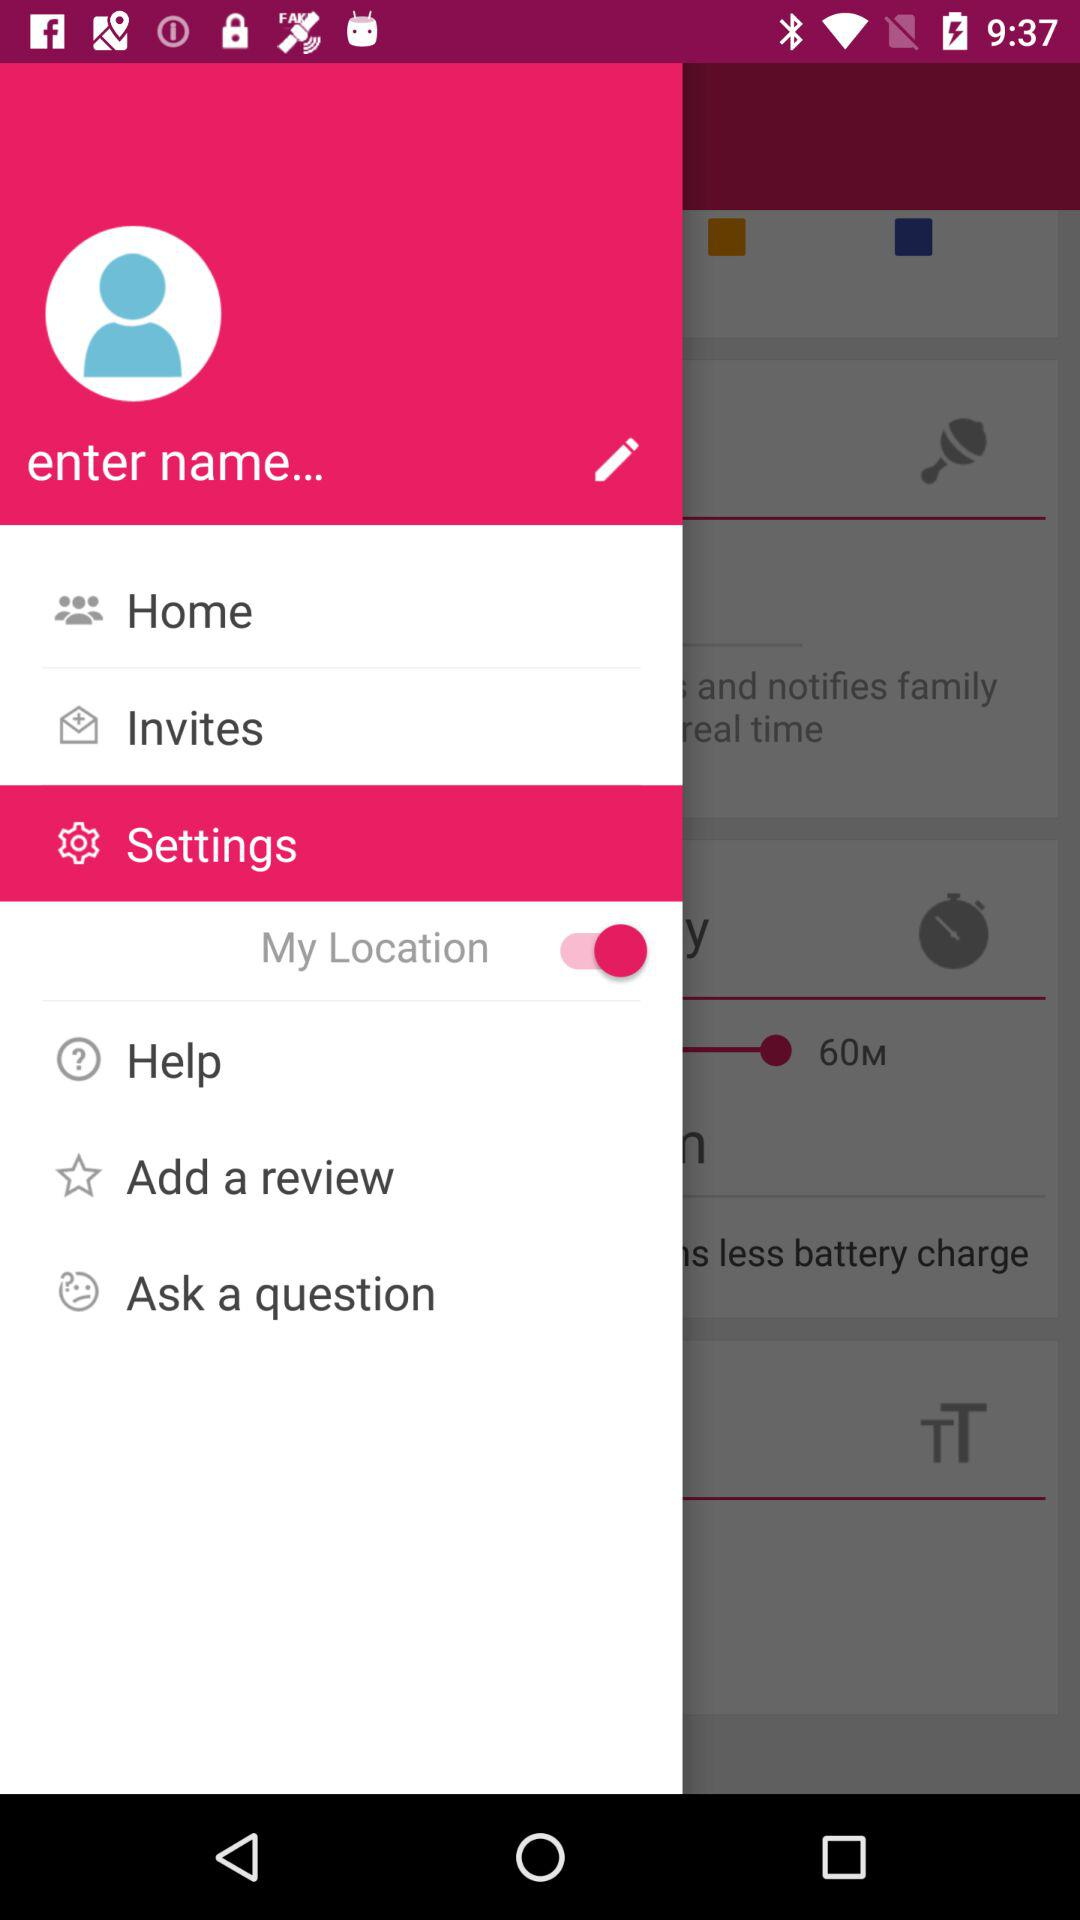What is the status of "My Location"? The status is "on". 